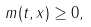<formula> <loc_0><loc_0><loc_500><loc_500>m ( t , x ) \geq 0 ,</formula> 